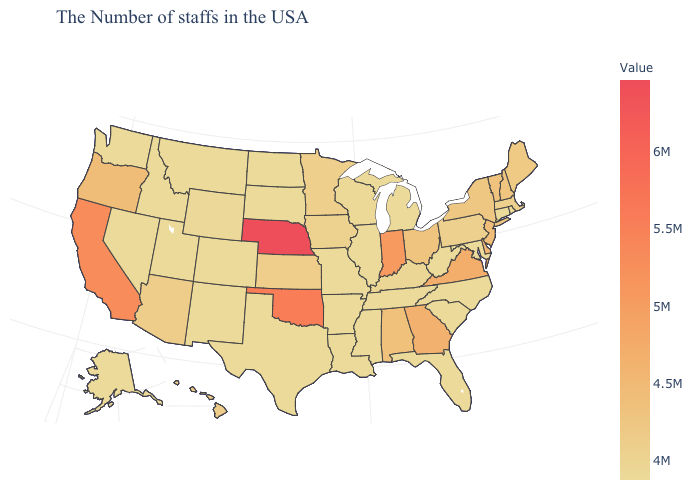Does South Dakota have the lowest value in the MidWest?
Write a very short answer. Yes. Among the states that border South Carolina , does Georgia have the lowest value?
Write a very short answer. No. Does Alabama have the lowest value in the USA?
Quick response, please. No. Which states hav the highest value in the Northeast?
Give a very brief answer. New Jersey. Among the states that border Illinois , which have the highest value?
Be succinct. Indiana. Among the states that border California , does Nevada have the lowest value?
Give a very brief answer. Yes. 